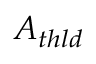<formula> <loc_0><loc_0><loc_500><loc_500>A _ { t h l d }</formula> 